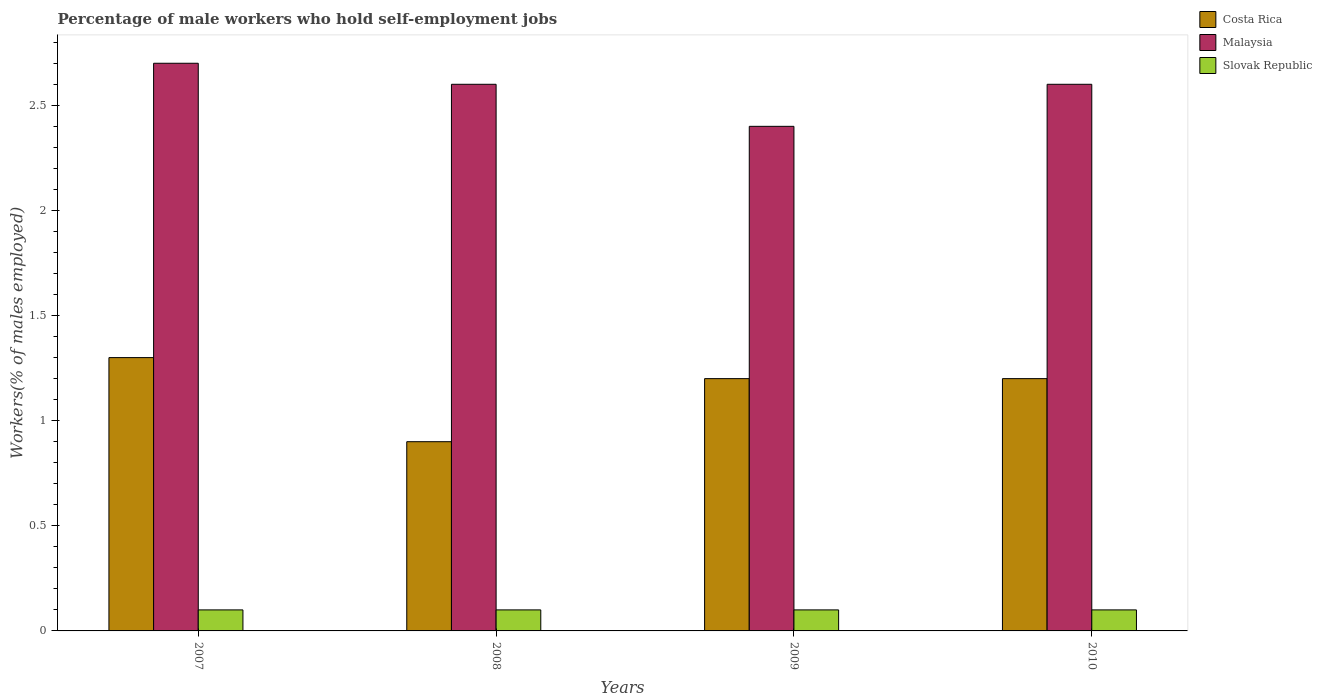How many different coloured bars are there?
Provide a succinct answer. 3. How many groups of bars are there?
Provide a short and direct response. 4. Are the number of bars per tick equal to the number of legend labels?
Your response must be concise. Yes. Are the number of bars on each tick of the X-axis equal?
Keep it short and to the point. Yes. How many bars are there on the 3rd tick from the left?
Offer a very short reply. 3. How many bars are there on the 2nd tick from the right?
Ensure brevity in your answer.  3. What is the percentage of self-employed male workers in Malaysia in 2010?
Your response must be concise. 2.6. Across all years, what is the maximum percentage of self-employed male workers in Costa Rica?
Make the answer very short. 1.3. Across all years, what is the minimum percentage of self-employed male workers in Slovak Republic?
Provide a succinct answer. 0.1. In which year was the percentage of self-employed male workers in Costa Rica maximum?
Keep it short and to the point. 2007. What is the total percentage of self-employed male workers in Malaysia in the graph?
Provide a short and direct response. 10.3. What is the difference between the percentage of self-employed male workers in Slovak Republic in 2007 and that in 2008?
Give a very brief answer. 0. What is the difference between the percentage of self-employed male workers in Slovak Republic in 2008 and the percentage of self-employed male workers in Costa Rica in 2007?
Give a very brief answer. -1.2. What is the average percentage of self-employed male workers in Costa Rica per year?
Ensure brevity in your answer.  1.15. In the year 2009, what is the difference between the percentage of self-employed male workers in Slovak Republic and percentage of self-employed male workers in Costa Rica?
Make the answer very short. -1.1. What is the ratio of the percentage of self-employed male workers in Slovak Republic in 2007 to that in 2010?
Provide a succinct answer. 1. Is the difference between the percentage of self-employed male workers in Slovak Republic in 2008 and 2010 greater than the difference between the percentage of self-employed male workers in Costa Rica in 2008 and 2010?
Make the answer very short. Yes. What is the difference between the highest and the second highest percentage of self-employed male workers in Malaysia?
Give a very brief answer. 0.1. What is the difference between the highest and the lowest percentage of self-employed male workers in Costa Rica?
Offer a very short reply. 0.4. What does the 3rd bar from the left in 2009 represents?
Offer a terse response. Slovak Republic. What does the 3rd bar from the right in 2010 represents?
Offer a terse response. Costa Rica. Is it the case that in every year, the sum of the percentage of self-employed male workers in Costa Rica and percentage of self-employed male workers in Malaysia is greater than the percentage of self-employed male workers in Slovak Republic?
Give a very brief answer. Yes. Does the graph contain any zero values?
Offer a very short reply. No. Does the graph contain grids?
Give a very brief answer. No. Where does the legend appear in the graph?
Offer a terse response. Top right. How many legend labels are there?
Keep it short and to the point. 3. What is the title of the graph?
Your response must be concise. Percentage of male workers who hold self-employment jobs. What is the label or title of the X-axis?
Offer a terse response. Years. What is the label or title of the Y-axis?
Provide a short and direct response. Workers(% of males employed). What is the Workers(% of males employed) in Costa Rica in 2007?
Ensure brevity in your answer.  1.3. What is the Workers(% of males employed) in Malaysia in 2007?
Offer a very short reply. 2.7. What is the Workers(% of males employed) of Slovak Republic in 2007?
Your answer should be compact. 0.1. What is the Workers(% of males employed) of Costa Rica in 2008?
Your response must be concise. 0.9. What is the Workers(% of males employed) of Malaysia in 2008?
Keep it short and to the point. 2.6. What is the Workers(% of males employed) of Slovak Republic in 2008?
Your answer should be very brief. 0.1. What is the Workers(% of males employed) in Costa Rica in 2009?
Provide a short and direct response. 1.2. What is the Workers(% of males employed) in Malaysia in 2009?
Provide a short and direct response. 2.4. What is the Workers(% of males employed) in Slovak Republic in 2009?
Offer a terse response. 0.1. What is the Workers(% of males employed) in Costa Rica in 2010?
Offer a very short reply. 1.2. What is the Workers(% of males employed) of Malaysia in 2010?
Your response must be concise. 2.6. What is the Workers(% of males employed) in Slovak Republic in 2010?
Your response must be concise. 0.1. Across all years, what is the maximum Workers(% of males employed) in Costa Rica?
Offer a terse response. 1.3. Across all years, what is the maximum Workers(% of males employed) in Malaysia?
Make the answer very short. 2.7. Across all years, what is the maximum Workers(% of males employed) of Slovak Republic?
Ensure brevity in your answer.  0.1. Across all years, what is the minimum Workers(% of males employed) of Costa Rica?
Give a very brief answer. 0.9. Across all years, what is the minimum Workers(% of males employed) of Malaysia?
Your response must be concise. 2.4. Across all years, what is the minimum Workers(% of males employed) in Slovak Republic?
Your answer should be compact. 0.1. What is the total Workers(% of males employed) of Costa Rica in the graph?
Make the answer very short. 4.6. What is the total Workers(% of males employed) of Malaysia in the graph?
Keep it short and to the point. 10.3. What is the total Workers(% of males employed) in Slovak Republic in the graph?
Give a very brief answer. 0.4. What is the difference between the Workers(% of males employed) in Slovak Republic in 2007 and that in 2009?
Provide a succinct answer. 0. What is the difference between the Workers(% of males employed) of Costa Rica in 2007 and that in 2010?
Provide a short and direct response. 0.1. What is the difference between the Workers(% of males employed) in Malaysia in 2007 and that in 2010?
Your answer should be very brief. 0.1. What is the difference between the Workers(% of males employed) in Malaysia in 2008 and that in 2009?
Provide a succinct answer. 0.2. What is the difference between the Workers(% of males employed) in Costa Rica in 2009 and that in 2010?
Offer a terse response. 0. What is the difference between the Workers(% of males employed) of Costa Rica in 2007 and the Workers(% of males employed) of Malaysia in 2008?
Offer a very short reply. -1.3. What is the difference between the Workers(% of males employed) in Malaysia in 2007 and the Workers(% of males employed) in Slovak Republic in 2008?
Offer a very short reply. 2.6. What is the difference between the Workers(% of males employed) in Costa Rica in 2007 and the Workers(% of males employed) in Malaysia in 2010?
Give a very brief answer. -1.3. What is the difference between the Workers(% of males employed) in Malaysia in 2008 and the Workers(% of males employed) in Slovak Republic in 2009?
Ensure brevity in your answer.  2.5. What is the difference between the Workers(% of males employed) of Malaysia in 2008 and the Workers(% of males employed) of Slovak Republic in 2010?
Keep it short and to the point. 2.5. What is the difference between the Workers(% of males employed) in Costa Rica in 2009 and the Workers(% of males employed) in Slovak Republic in 2010?
Offer a terse response. 1.1. What is the average Workers(% of males employed) in Costa Rica per year?
Provide a short and direct response. 1.15. What is the average Workers(% of males employed) of Malaysia per year?
Provide a succinct answer. 2.58. What is the average Workers(% of males employed) of Slovak Republic per year?
Your response must be concise. 0.1. In the year 2007, what is the difference between the Workers(% of males employed) in Costa Rica and Workers(% of males employed) in Malaysia?
Give a very brief answer. -1.4. In the year 2008, what is the difference between the Workers(% of males employed) of Costa Rica and Workers(% of males employed) of Malaysia?
Keep it short and to the point. -1.7. In the year 2008, what is the difference between the Workers(% of males employed) of Costa Rica and Workers(% of males employed) of Slovak Republic?
Your answer should be compact. 0.8. In the year 2009, what is the difference between the Workers(% of males employed) in Costa Rica and Workers(% of males employed) in Malaysia?
Make the answer very short. -1.2. In the year 2009, what is the difference between the Workers(% of males employed) in Malaysia and Workers(% of males employed) in Slovak Republic?
Offer a very short reply. 2.3. In the year 2010, what is the difference between the Workers(% of males employed) of Costa Rica and Workers(% of males employed) of Malaysia?
Offer a very short reply. -1.4. What is the ratio of the Workers(% of males employed) of Costa Rica in 2007 to that in 2008?
Make the answer very short. 1.44. What is the ratio of the Workers(% of males employed) in Malaysia in 2007 to that in 2008?
Offer a terse response. 1.04. What is the ratio of the Workers(% of males employed) in Slovak Republic in 2007 to that in 2008?
Give a very brief answer. 1. What is the ratio of the Workers(% of males employed) in Malaysia in 2007 to that in 2009?
Offer a terse response. 1.12. What is the ratio of the Workers(% of males employed) in Costa Rica in 2007 to that in 2010?
Give a very brief answer. 1.08. What is the ratio of the Workers(% of males employed) in Malaysia in 2007 to that in 2010?
Provide a short and direct response. 1.04. What is the ratio of the Workers(% of males employed) of Slovak Republic in 2007 to that in 2010?
Your answer should be very brief. 1. What is the ratio of the Workers(% of males employed) in Malaysia in 2008 to that in 2009?
Offer a terse response. 1.08. What is the ratio of the Workers(% of males employed) in Slovak Republic in 2008 to that in 2009?
Ensure brevity in your answer.  1. What is the ratio of the Workers(% of males employed) in Slovak Republic in 2009 to that in 2010?
Keep it short and to the point. 1. What is the difference between the highest and the lowest Workers(% of males employed) of Costa Rica?
Offer a terse response. 0.4. What is the difference between the highest and the lowest Workers(% of males employed) in Slovak Republic?
Your answer should be compact. 0. 